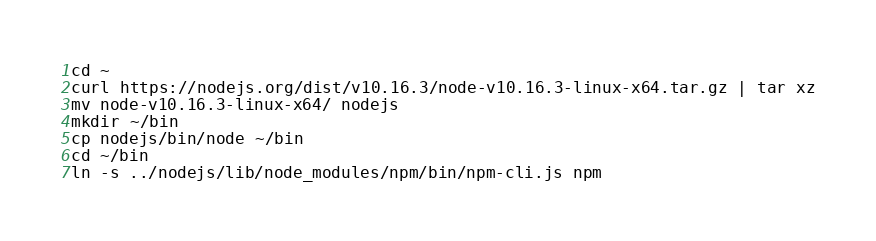Convert code to text. <code><loc_0><loc_0><loc_500><loc_500><_Bash_>cd ~
curl https://nodejs.org/dist/v10.16.3/node-v10.16.3-linux-x64.tar.gz | tar xz
mv node-v10.16.3-linux-x64/ nodejs
mkdir ~/bin
cp nodejs/bin/node ~/bin
cd ~/bin
ln -s ../nodejs/lib/node_modules/npm/bin/npm-cli.js npm</code> 